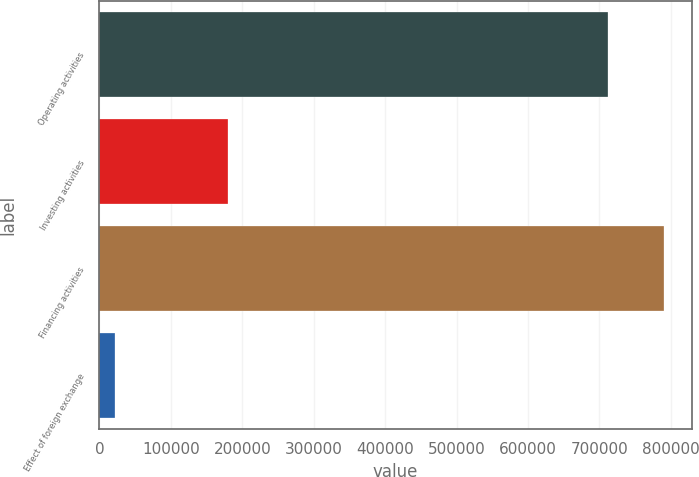Convert chart. <chart><loc_0><loc_0><loc_500><loc_500><bar_chart><fcel>Operating activities<fcel>Investing activities<fcel>Financing activities<fcel>Effect of foreign exchange<nl><fcel>712069<fcel>179506<fcel>789979<fcel>21528<nl></chart> 